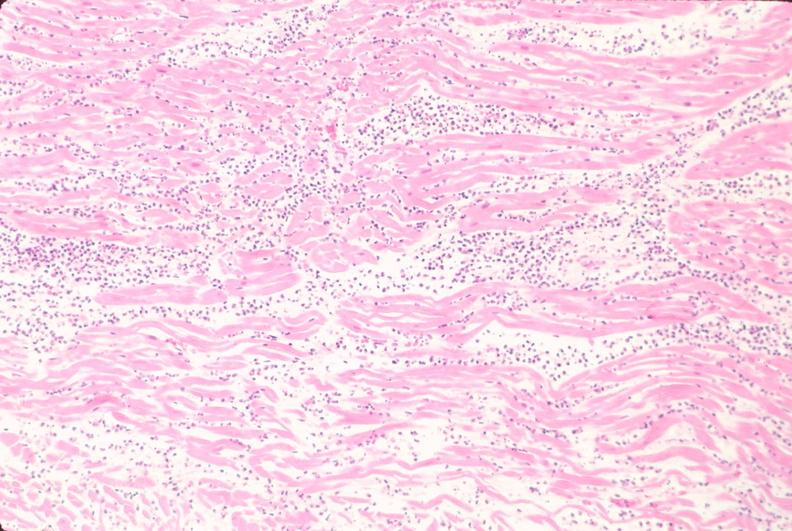does this image show heart, acute myocardial infarction, he?
Answer the question using a single word or phrase. Yes 